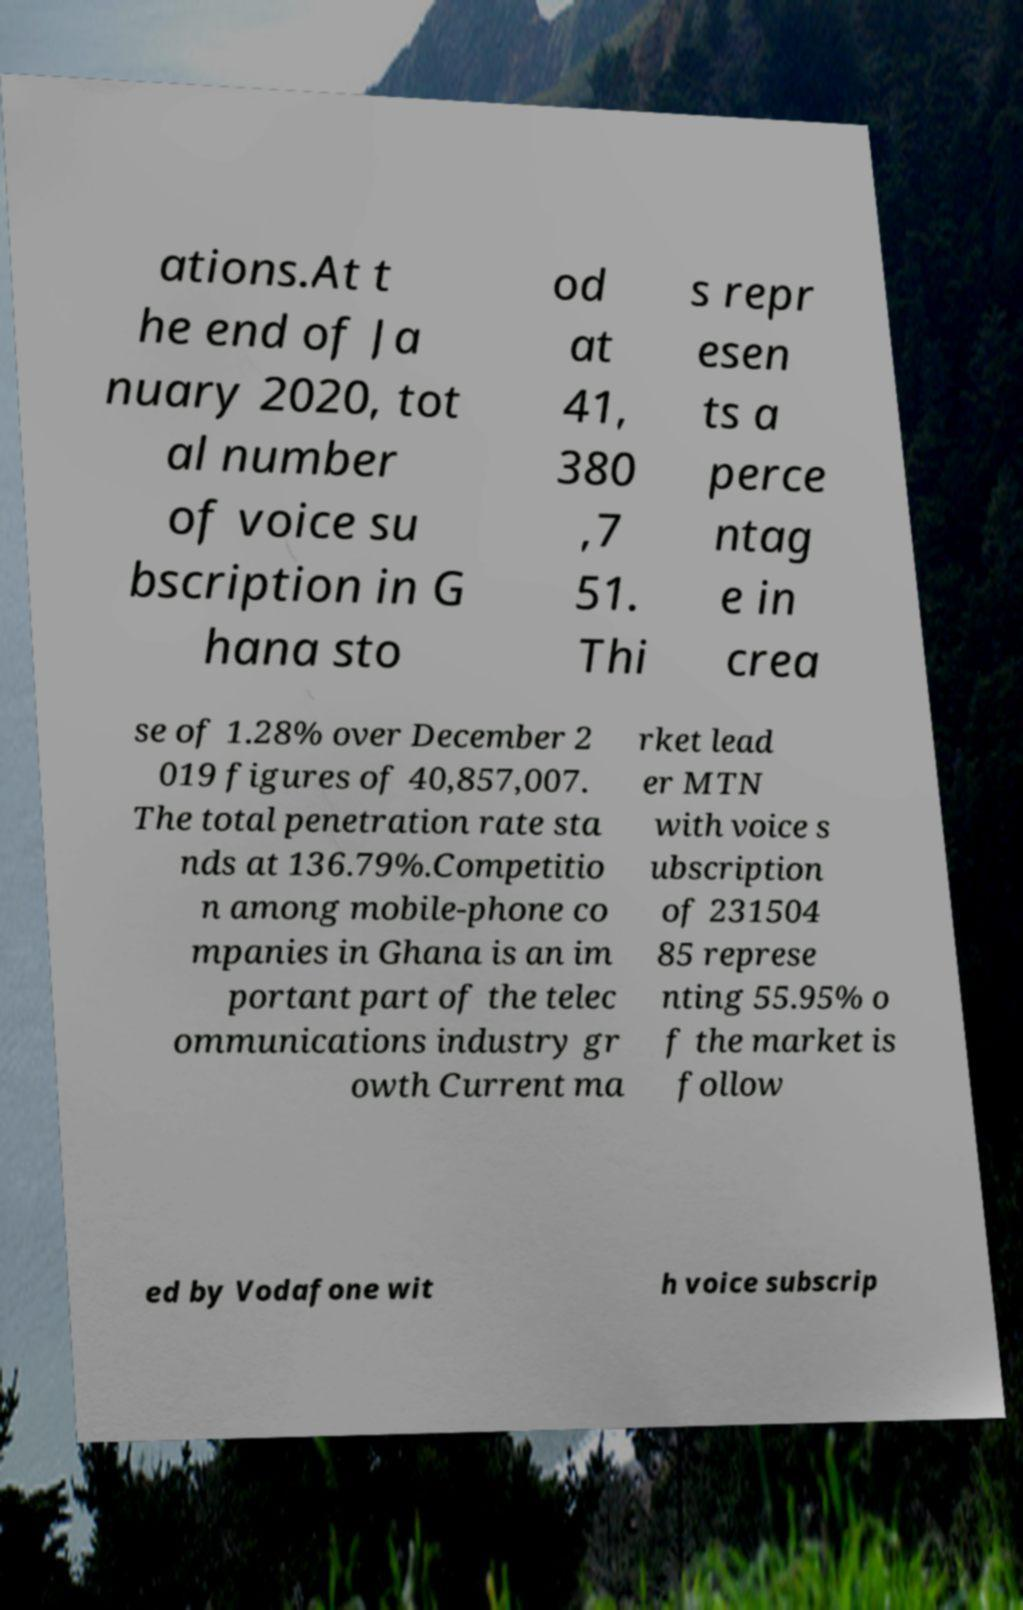What messages or text are displayed in this image? I need them in a readable, typed format. ations.At t he end of Ja nuary 2020, tot al number of voice su bscription in G hana sto od at 41, 380 ,7 51. Thi s repr esen ts a perce ntag e in crea se of 1.28% over December 2 019 figures of 40,857,007. The total penetration rate sta nds at 136.79%.Competitio n among mobile-phone co mpanies in Ghana is an im portant part of the telec ommunications industry gr owth Current ma rket lead er MTN with voice s ubscription of 231504 85 represe nting 55.95% o f the market is follow ed by Vodafone wit h voice subscrip 